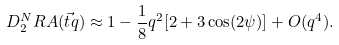<formula> <loc_0><loc_0><loc_500><loc_500>D _ { 2 } ^ { N } R A ( \vec { t } { q } ) \approx 1 - \frac { 1 } { 8 } q ^ { 2 } [ 2 + 3 \cos ( 2 \psi ) ] + O ( q ^ { 4 } ) .</formula> 